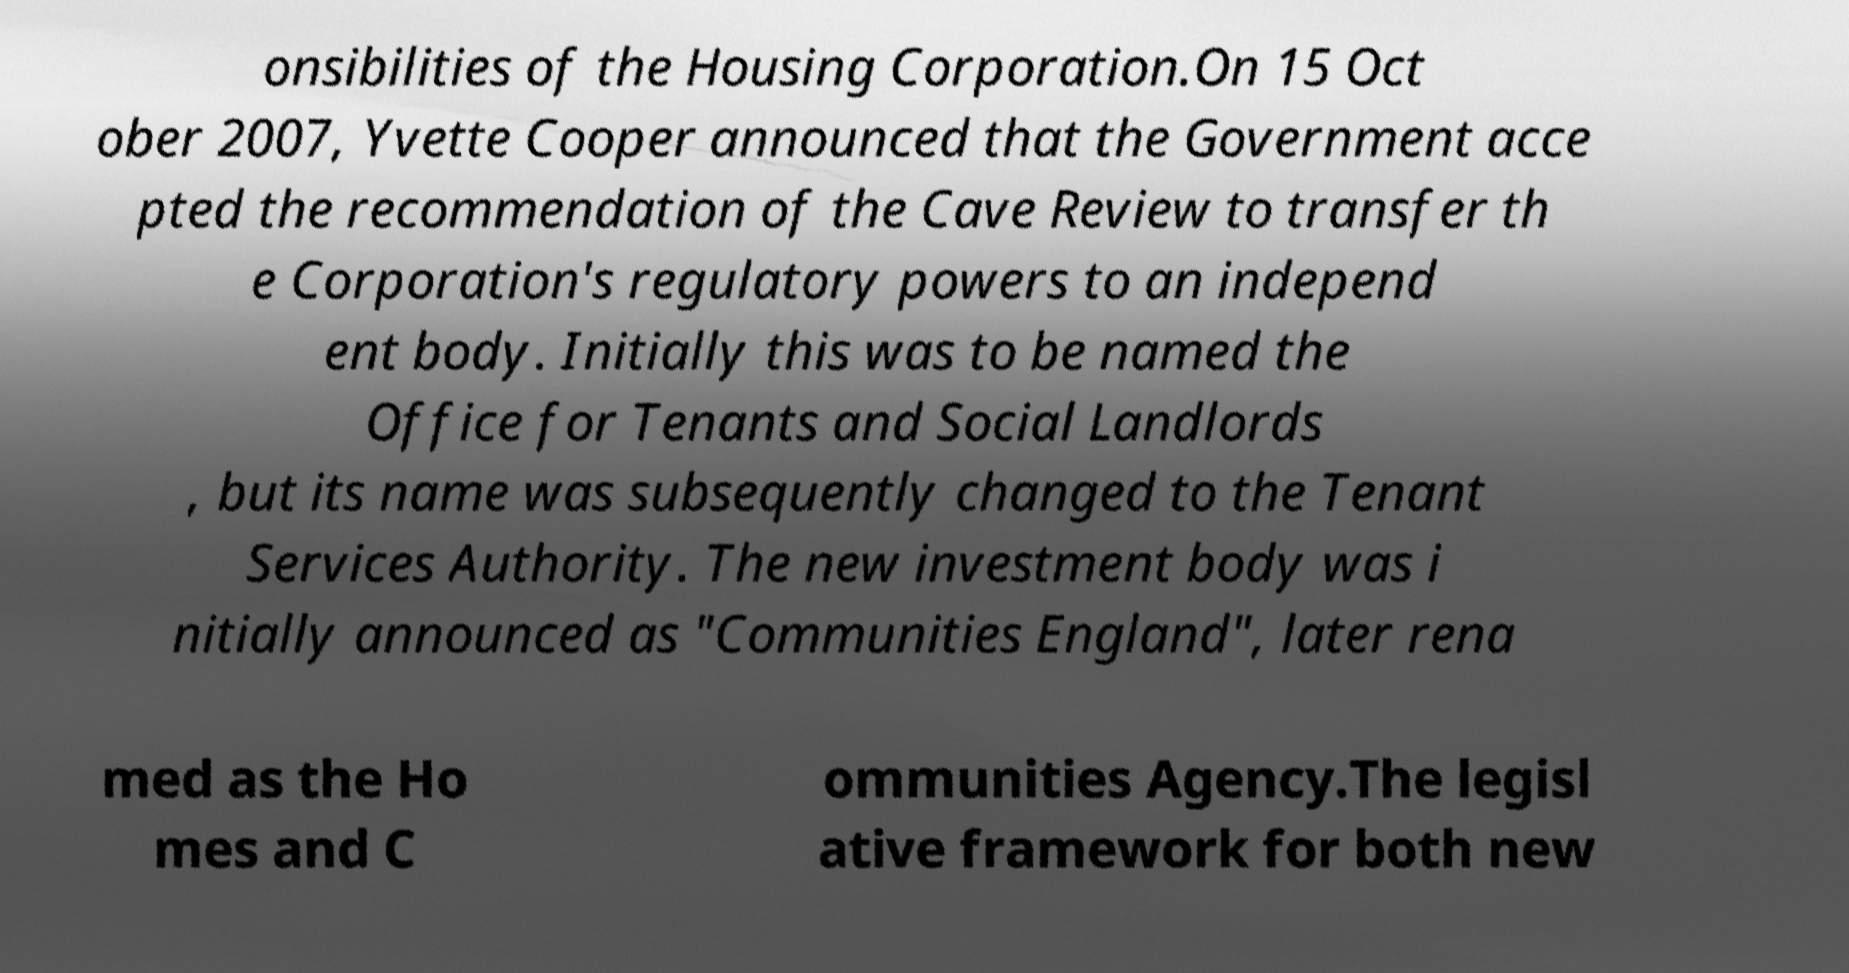Could you assist in decoding the text presented in this image and type it out clearly? onsibilities of the Housing Corporation.On 15 Oct ober 2007, Yvette Cooper announced that the Government acce pted the recommendation of the Cave Review to transfer th e Corporation's regulatory powers to an independ ent body. Initially this was to be named the Office for Tenants and Social Landlords , but its name was subsequently changed to the Tenant Services Authority. The new investment body was i nitially announced as "Communities England", later rena med as the Ho mes and C ommunities Agency.The legisl ative framework for both new 